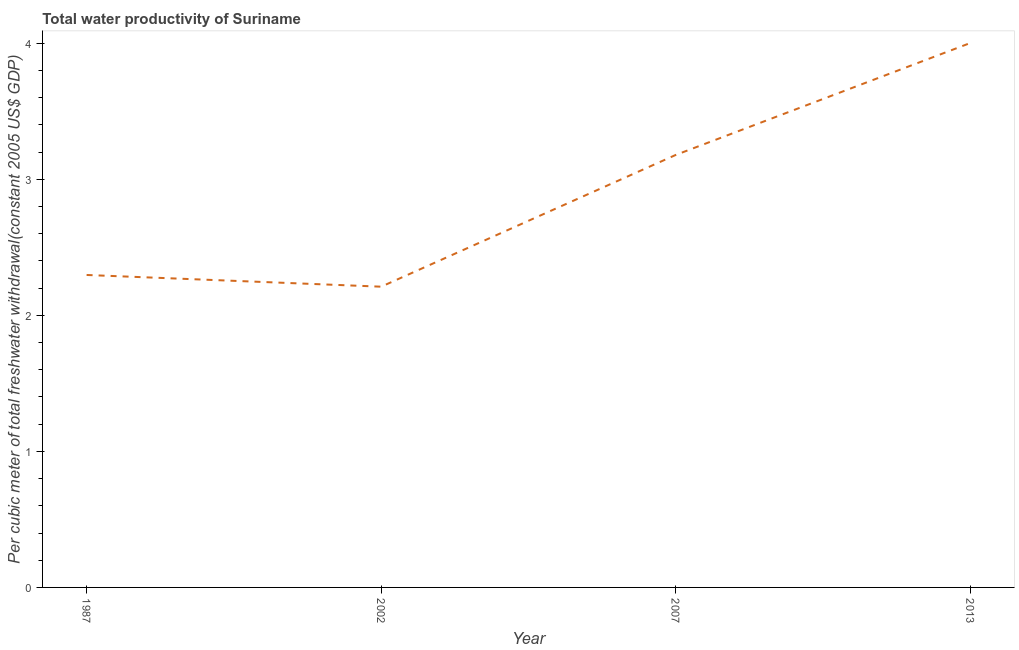What is the total water productivity in 1987?
Provide a succinct answer. 2.3. Across all years, what is the maximum total water productivity?
Your answer should be compact. 4. Across all years, what is the minimum total water productivity?
Give a very brief answer. 2.21. In which year was the total water productivity minimum?
Your answer should be compact. 2002. What is the sum of the total water productivity?
Give a very brief answer. 11.69. What is the difference between the total water productivity in 1987 and 2013?
Offer a terse response. -1.7. What is the average total water productivity per year?
Offer a very short reply. 2.92. What is the median total water productivity?
Provide a short and direct response. 2.74. In how many years, is the total water productivity greater than 0.4 US$?
Keep it short and to the point. 4. Do a majority of the years between 2013 and 2002 (inclusive) have total water productivity greater than 3 US$?
Offer a very short reply. No. What is the ratio of the total water productivity in 2002 to that in 2007?
Your answer should be compact. 0.7. Is the difference between the total water productivity in 2002 and 2007 greater than the difference between any two years?
Give a very brief answer. No. What is the difference between the highest and the second highest total water productivity?
Keep it short and to the point. 0.82. Is the sum of the total water productivity in 1987 and 2013 greater than the maximum total water productivity across all years?
Keep it short and to the point. Yes. What is the difference between the highest and the lowest total water productivity?
Your answer should be compact. 1.79. Does the total water productivity monotonically increase over the years?
Make the answer very short. No. How many years are there in the graph?
Keep it short and to the point. 4. Does the graph contain any zero values?
Provide a short and direct response. No. Does the graph contain grids?
Your response must be concise. No. What is the title of the graph?
Provide a short and direct response. Total water productivity of Suriname. What is the label or title of the Y-axis?
Your answer should be very brief. Per cubic meter of total freshwater withdrawal(constant 2005 US$ GDP). What is the Per cubic meter of total freshwater withdrawal(constant 2005 US$ GDP) of 1987?
Make the answer very short. 2.3. What is the Per cubic meter of total freshwater withdrawal(constant 2005 US$ GDP) of 2002?
Make the answer very short. 2.21. What is the Per cubic meter of total freshwater withdrawal(constant 2005 US$ GDP) in 2007?
Provide a succinct answer. 3.18. What is the Per cubic meter of total freshwater withdrawal(constant 2005 US$ GDP) in 2013?
Your response must be concise. 4. What is the difference between the Per cubic meter of total freshwater withdrawal(constant 2005 US$ GDP) in 1987 and 2002?
Your response must be concise. 0.09. What is the difference between the Per cubic meter of total freshwater withdrawal(constant 2005 US$ GDP) in 1987 and 2007?
Offer a terse response. -0.88. What is the difference between the Per cubic meter of total freshwater withdrawal(constant 2005 US$ GDP) in 1987 and 2013?
Offer a very short reply. -1.7. What is the difference between the Per cubic meter of total freshwater withdrawal(constant 2005 US$ GDP) in 2002 and 2007?
Offer a terse response. -0.97. What is the difference between the Per cubic meter of total freshwater withdrawal(constant 2005 US$ GDP) in 2002 and 2013?
Ensure brevity in your answer.  -1.79. What is the difference between the Per cubic meter of total freshwater withdrawal(constant 2005 US$ GDP) in 2007 and 2013?
Offer a terse response. -0.82. What is the ratio of the Per cubic meter of total freshwater withdrawal(constant 2005 US$ GDP) in 1987 to that in 2002?
Your response must be concise. 1.04. What is the ratio of the Per cubic meter of total freshwater withdrawal(constant 2005 US$ GDP) in 1987 to that in 2007?
Provide a succinct answer. 0.72. What is the ratio of the Per cubic meter of total freshwater withdrawal(constant 2005 US$ GDP) in 1987 to that in 2013?
Ensure brevity in your answer.  0.57. What is the ratio of the Per cubic meter of total freshwater withdrawal(constant 2005 US$ GDP) in 2002 to that in 2007?
Your answer should be very brief. 0.69. What is the ratio of the Per cubic meter of total freshwater withdrawal(constant 2005 US$ GDP) in 2002 to that in 2013?
Your response must be concise. 0.55. What is the ratio of the Per cubic meter of total freshwater withdrawal(constant 2005 US$ GDP) in 2007 to that in 2013?
Offer a very short reply. 0.79. 